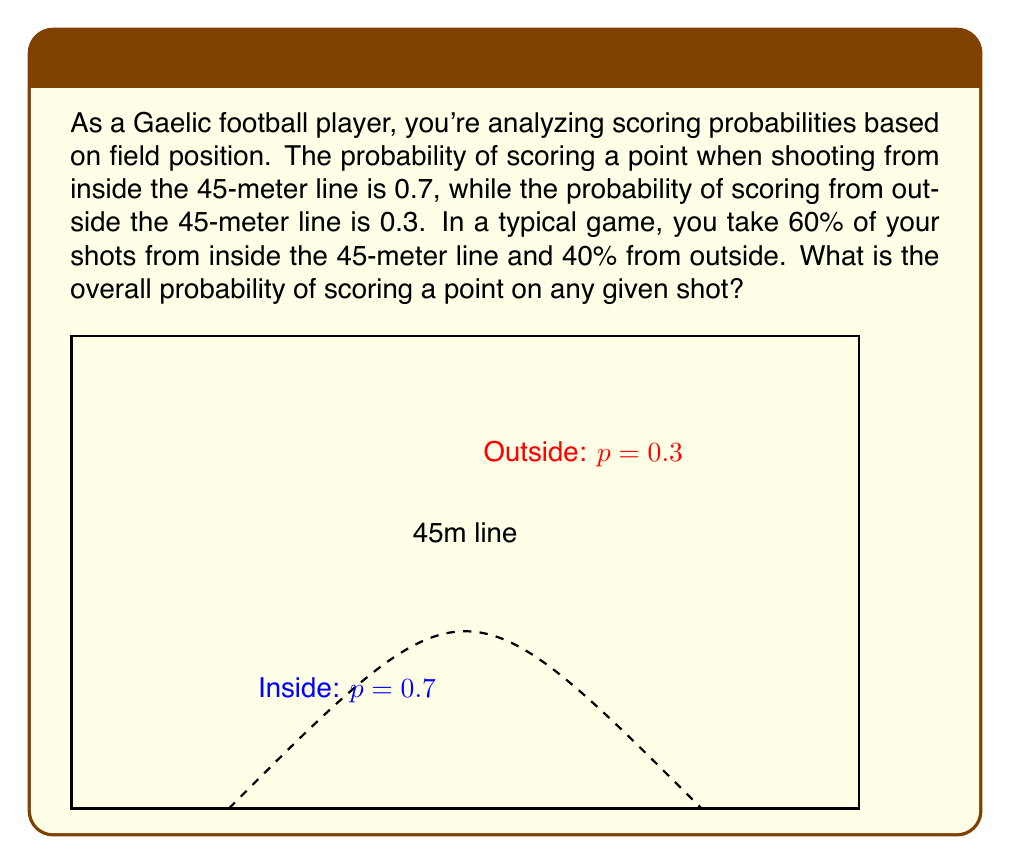Provide a solution to this math problem. Let's approach this step-by-step using the law of total probability:

1) Let A be the event of scoring a point. We want to find P(A).
2) Let I be the event of shooting from inside the 45-meter line, and O be the event of shooting from outside.

3) We're given:
   P(A|I) = 0.7 (probability of scoring given inside shot)
   P(A|O) = 0.3 (probability of scoring given outside shot)
   P(I) = 0.6 (probability of shooting from inside)
   P(O) = 0.4 (probability of shooting from outside)

4) The law of total probability states:
   $$P(A) = P(A|I) \cdot P(I) + P(A|O) \cdot P(O)$$

5) Substituting the values:
   $$P(A) = 0.7 \cdot 0.6 + 0.3 \cdot 0.4$$

6) Calculating:
   $$P(A) = 0.42 + 0.12 = 0.54$$

Therefore, the overall probability of scoring a point on any given shot is 0.54 or 54%.
Answer: 0.54 